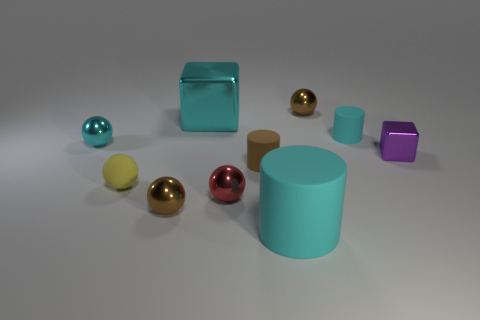Subtract all cyan cylinders. How many cylinders are left? 1 Subtract all cyan cylinders. How many cylinders are left? 1 Subtract 2 balls. How many balls are left? 3 Subtract all large cyan cylinders. Subtract all tiny cyan metallic spheres. How many objects are left? 8 Add 8 small brown metal objects. How many small brown metal objects are left? 10 Add 3 yellow cubes. How many yellow cubes exist? 3 Subtract 0 green spheres. How many objects are left? 10 Subtract all cubes. How many objects are left? 8 Subtract all yellow cylinders. Subtract all purple cubes. How many cylinders are left? 3 Subtract all red cubes. How many blue spheres are left? 0 